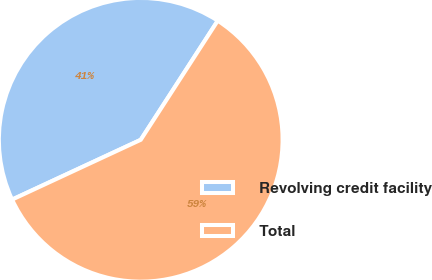<chart> <loc_0><loc_0><loc_500><loc_500><pie_chart><fcel>Revolving credit facility<fcel>Total<nl><fcel>41.06%<fcel>58.94%<nl></chart> 